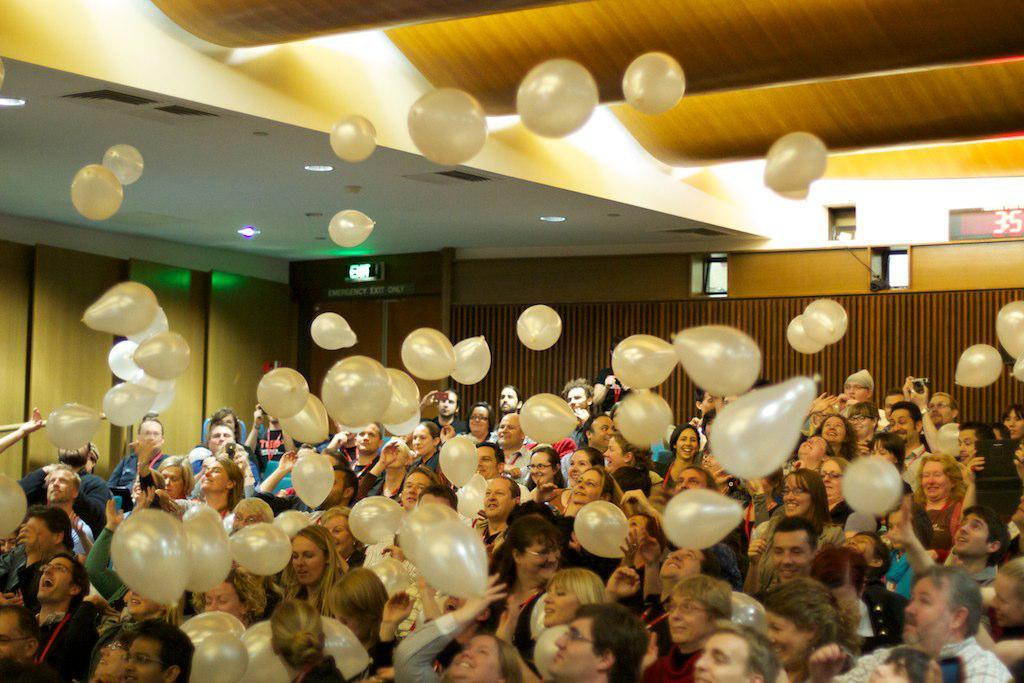Who or what can be seen in the image? There are people in the image. What else is present in the image besides people? There are balloons and lights visible in the image. What can be seen above the people in the image? The ceiling is visible in the image. What is on the side of the image? There is a wall in the image. Is there any text or writing in the image? Yes, there is a board with text in the image. Can you see any wood furniture in the image? There is no mention of wood furniture in the provided facts, so we cannot determine if it is present in the image. Are there any jellyfish swimming in the image? There is no mention of jellyfish in the provided facts, so we cannot determine if they are present in the image. 